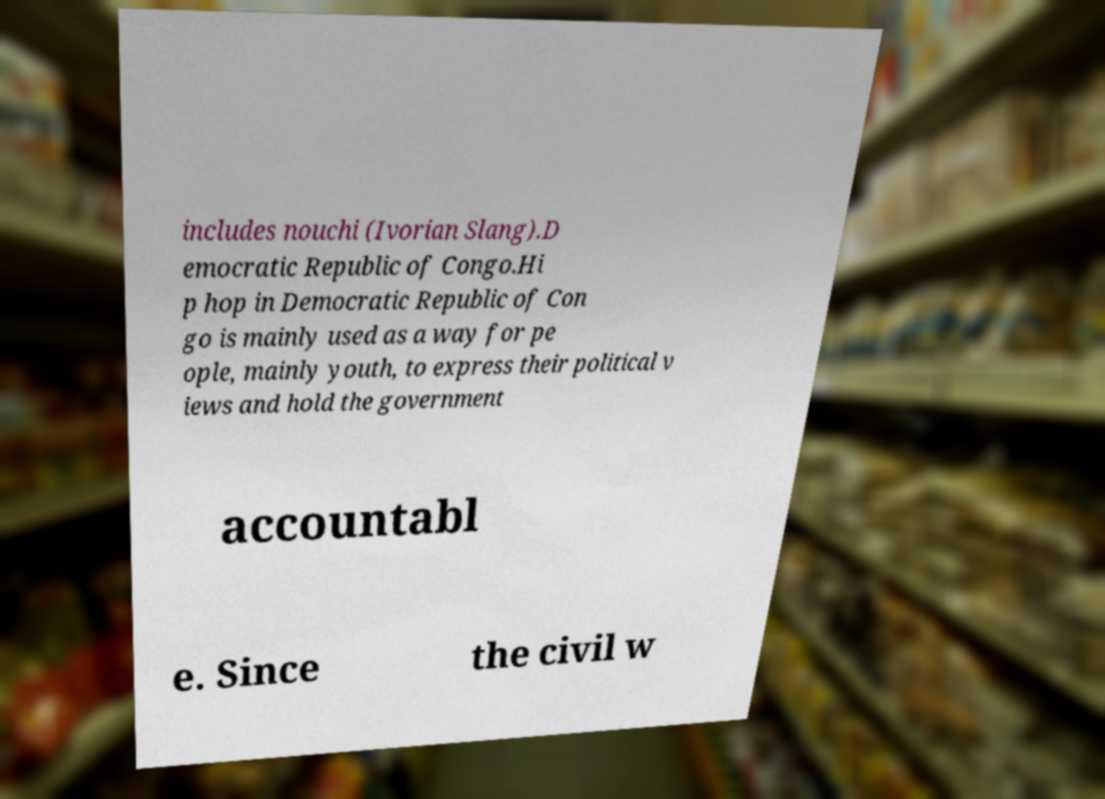Please read and relay the text visible in this image. What does it say? includes nouchi (Ivorian Slang).D emocratic Republic of Congo.Hi p hop in Democratic Republic of Con go is mainly used as a way for pe ople, mainly youth, to express their political v iews and hold the government accountabl e. Since the civil w 